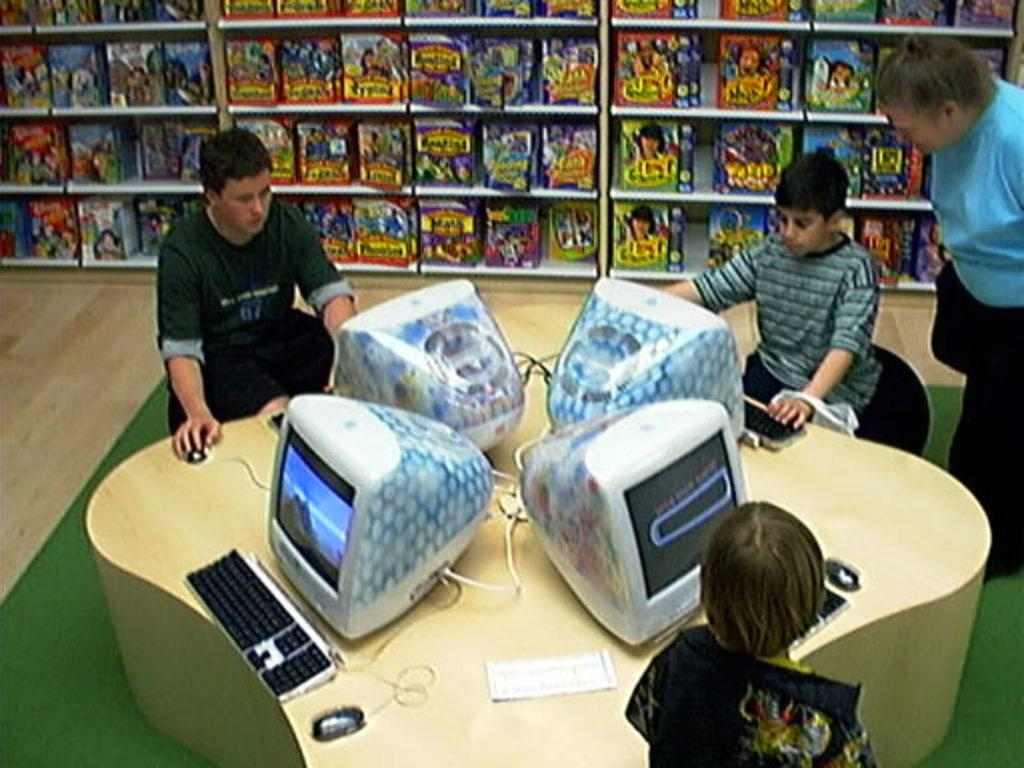What are the kids doing in the image? The kids are sitting on chairs in the image. What can be seen on the table in the image? There are monitors on the table in the image. What is the position of the person in the image? There is a person standing in the image. What type of objects can be seen on a shelf in the background of the image? There are books kept on a shelf in the background of the image. What time of day is it in the image, specifically in the afternoon? The time of day is not mentioned in the image, so it cannot be determined if it is specifically in the afternoon. 